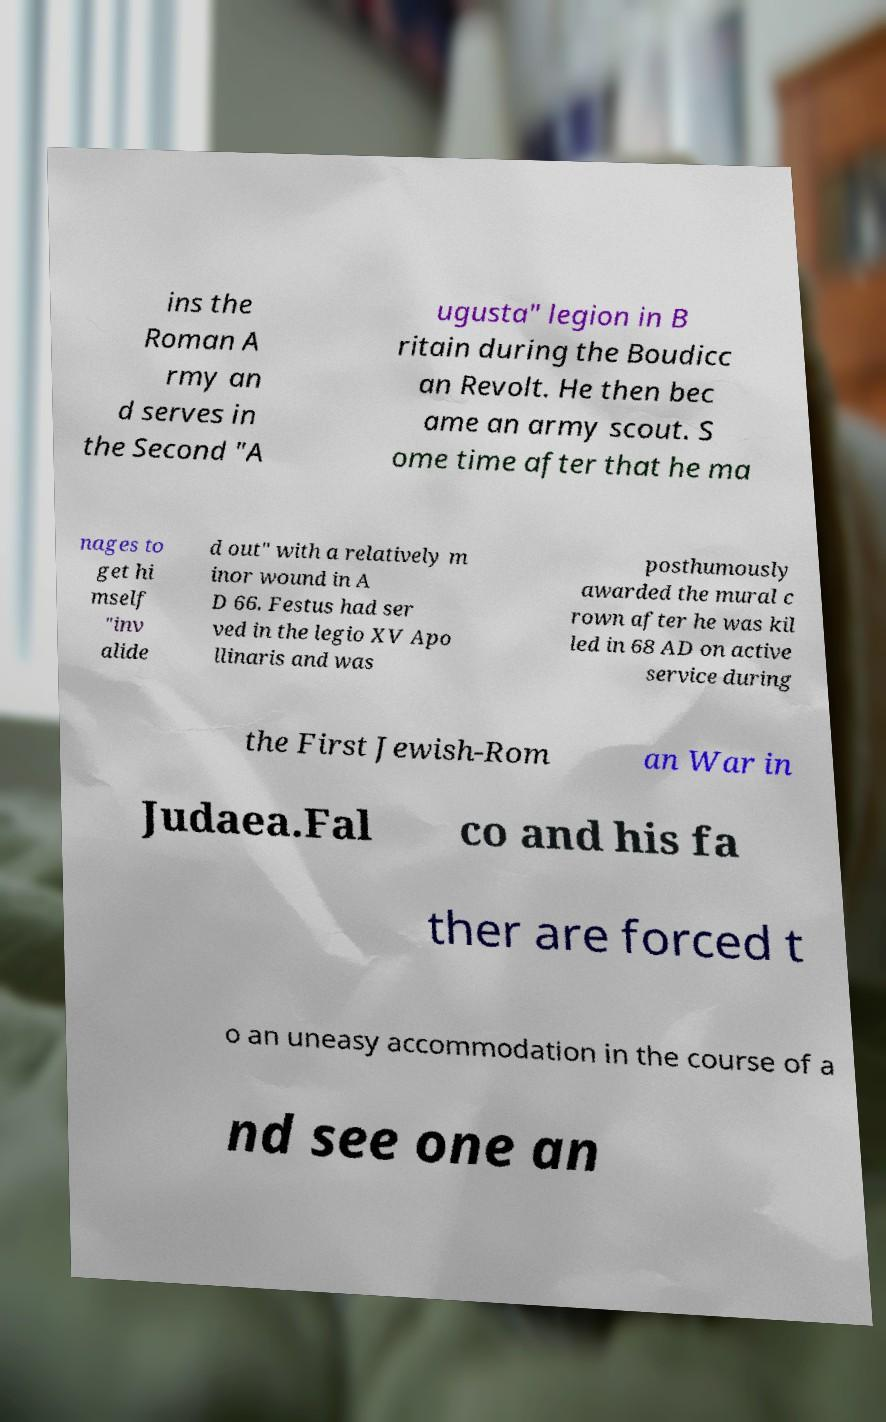There's text embedded in this image that I need extracted. Can you transcribe it verbatim? ins the Roman A rmy an d serves in the Second "A ugusta" legion in B ritain during the Boudicc an Revolt. He then bec ame an army scout. S ome time after that he ma nages to get hi mself "inv alide d out" with a relatively m inor wound in A D 66. Festus had ser ved in the legio XV Apo llinaris and was posthumously awarded the mural c rown after he was kil led in 68 AD on active service during the First Jewish-Rom an War in Judaea.Fal co and his fa ther are forced t o an uneasy accommodation in the course of a nd see one an 